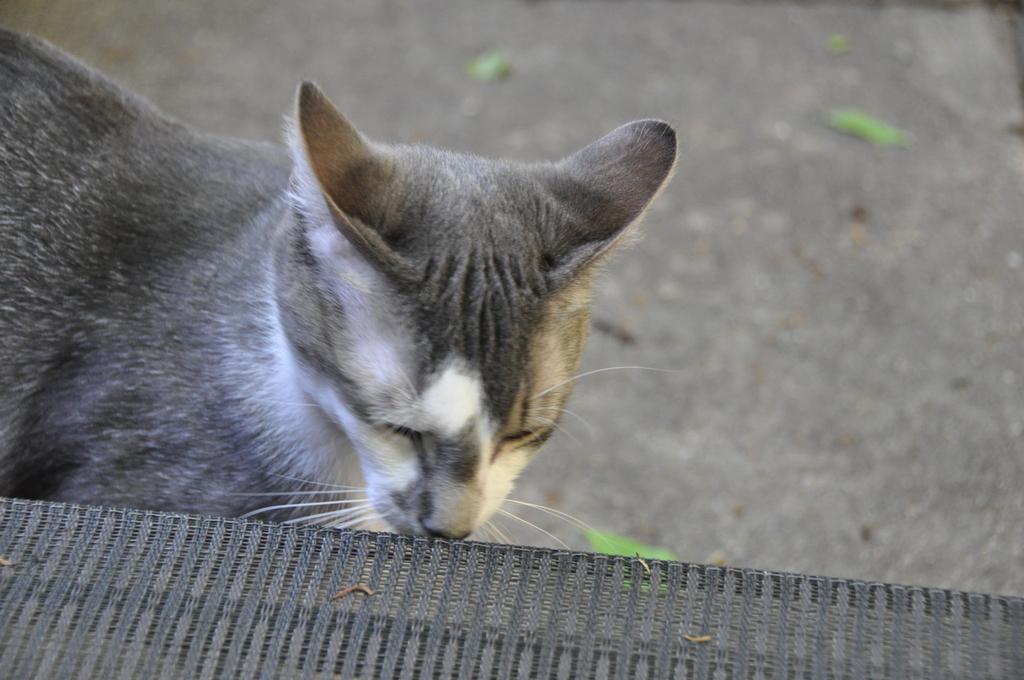In one or two sentences, can you explain what this image depicts? Here in this picture we can see a cat present on the road over there and it is smelling something, which is present in front of it over there. 